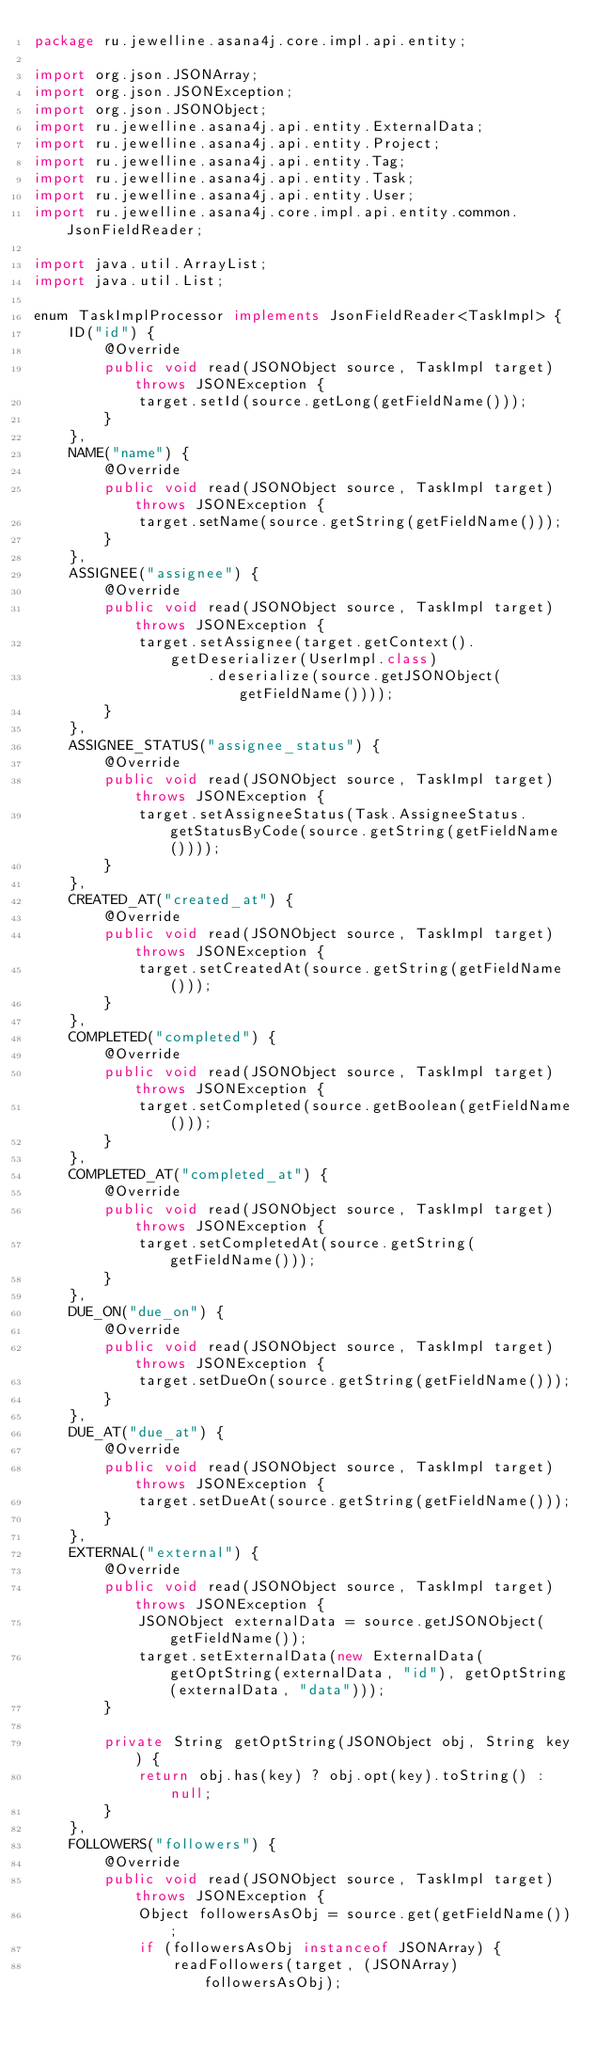Convert code to text. <code><loc_0><loc_0><loc_500><loc_500><_Java_>package ru.jewelline.asana4j.core.impl.api.entity;

import org.json.JSONArray;
import org.json.JSONException;
import org.json.JSONObject;
import ru.jewelline.asana4j.api.entity.ExternalData;
import ru.jewelline.asana4j.api.entity.Project;
import ru.jewelline.asana4j.api.entity.Tag;
import ru.jewelline.asana4j.api.entity.Task;
import ru.jewelline.asana4j.api.entity.User;
import ru.jewelline.asana4j.core.impl.api.entity.common.JsonFieldReader;

import java.util.ArrayList;
import java.util.List;

enum TaskImplProcessor implements JsonFieldReader<TaskImpl> {
    ID("id") {
        @Override
        public void read(JSONObject source, TaskImpl target) throws JSONException {
            target.setId(source.getLong(getFieldName()));
        }
    },
    NAME("name") {
        @Override
        public void read(JSONObject source, TaskImpl target) throws JSONException {
            target.setName(source.getString(getFieldName()));
        }
    },
    ASSIGNEE("assignee") {
        @Override
        public void read(JSONObject source, TaskImpl target) throws JSONException {
            target.setAssignee(target.getContext().getDeserializer(UserImpl.class)
                    .deserialize(source.getJSONObject(getFieldName())));
        }
    },
    ASSIGNEE_STATUS("assignee_status") {
        @Override
        public void read(JSONObject source, TaskImpl target) throws JSONException {
            target.setAssigneeStatus(Task.AssigneeStatus.getStatusByCode(source.getString(getFieldName())));
        }
    },
    CREATED_AT("created_at") {
        @Override
        public void read(JSONObject source, TaskImpl target) throws JSONException {
            target.setCreatedAt(source.getString(getFieldName()));
        }
    },
    COMPLETED("completed") {
        @Override
        public void read(JSONObject source, TaskImpl target) throws JSONException {
            target.setCompleted(source.getBoolean(getFieldName()));
        }
    },
    COMPLETED_AT("completed_at") {
        @Override
        public void read(JSONObject source, TaskImpl target) throws JSONException {
            target.setCompletedAt(source.getString(getFieldName()));
        }
    },
    DUE_ON("due_on") {
        @Override
        public void read(JSONObject source, TaskImpl target) throws JSONException {
            target.setDueOn(source.getString(getFieldName()));
        }
    },
    DUE_AT("due_at") {
        @Override
        public void read(JSONObject source, TaskImpl target) throws JSONException {
            target.setDueAt(source.getString(getFieldName()));
        }
    },
    EXTERNAL("external") {
        @Override
        public void read(JSONObject source, TaskImpl target) throws JSONException {
            JSONObject externalData = source.getJSONObject(getFieldName());
            target.setExternalData(new ExternalData(getOptString(externalData, "id"), getOptString(externalData, "data")));
        }

        private String getOptString(JSONObject obj, String key) {
            return obj.has(key) ? obj.opt(key).toString() : null;
        }
    },
    FOLLOWERS("followers") {
        @Override
        public void read(JSONObject source, TaskImpl target) throws JSONException {
            Object followersAsObj = source.get(getFieldName());
            if (followersAsObj instanceof JSONArray) {
                readFollowers(target, (JSONArray) followersAsObj);</code> 